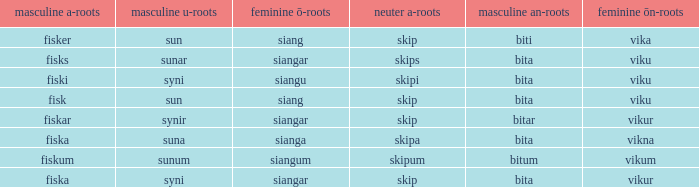What ending does siangu get for ön? Viku. 